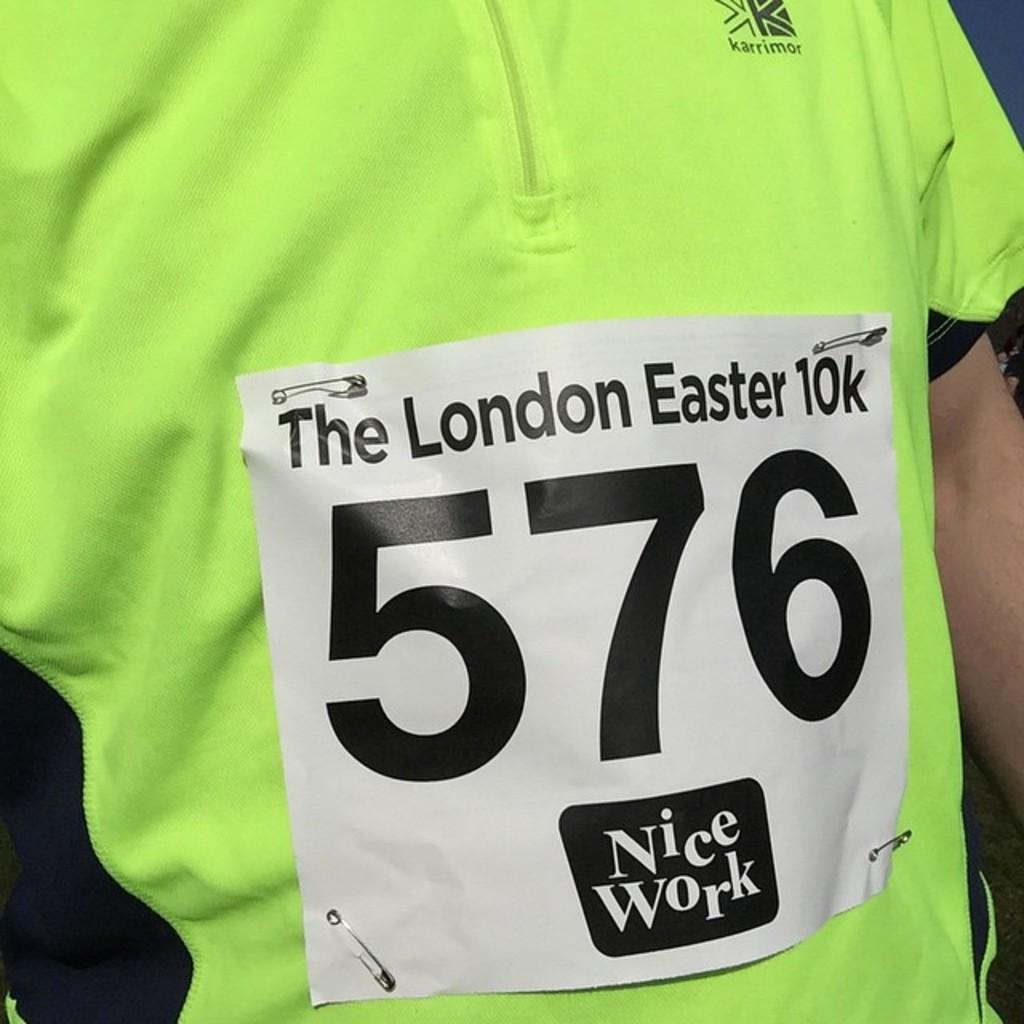<image>
Describe the image concisely. a sign that has the number 576 on it on a shirt 